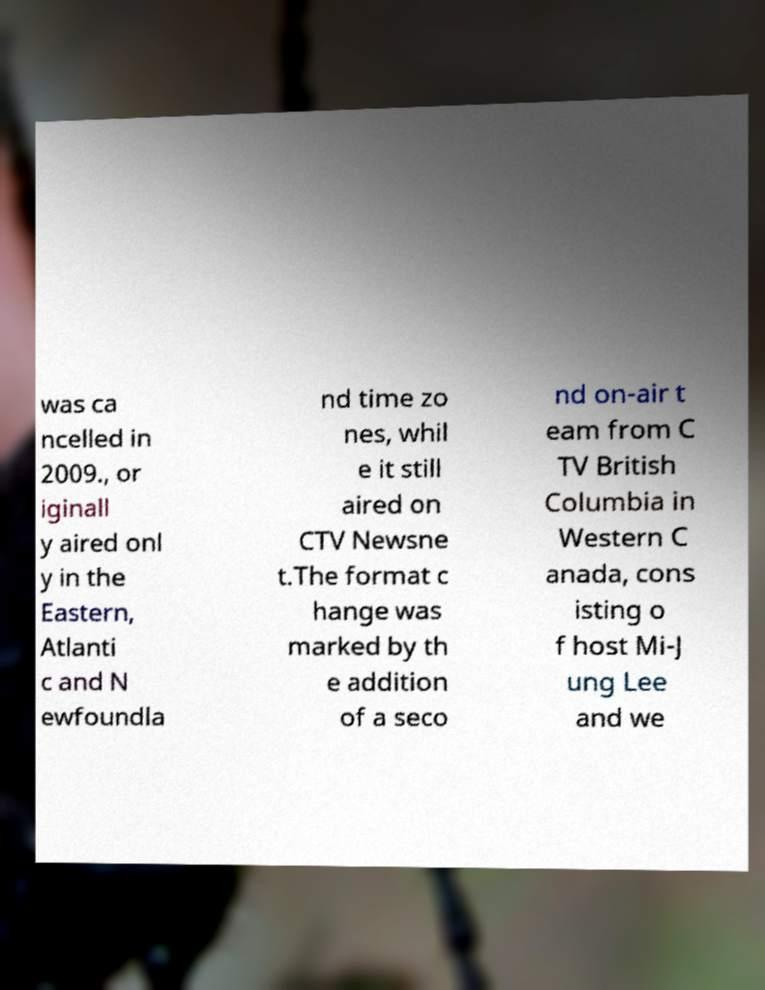Could you assist in decoding the text presented in this image and type it out clearly? was ca ncelled in 2009., or iginall y aired onl y in the Eastern, Atlanti c and N ewfoundla nd time zo nes, whil e it still aired on CTV Newsne t.The format c hange was marked by th e addition of a seco nd on-air t eam from C TV British Columbia in Western C anada, cons isting o f host Mi-J ung Lee and we 